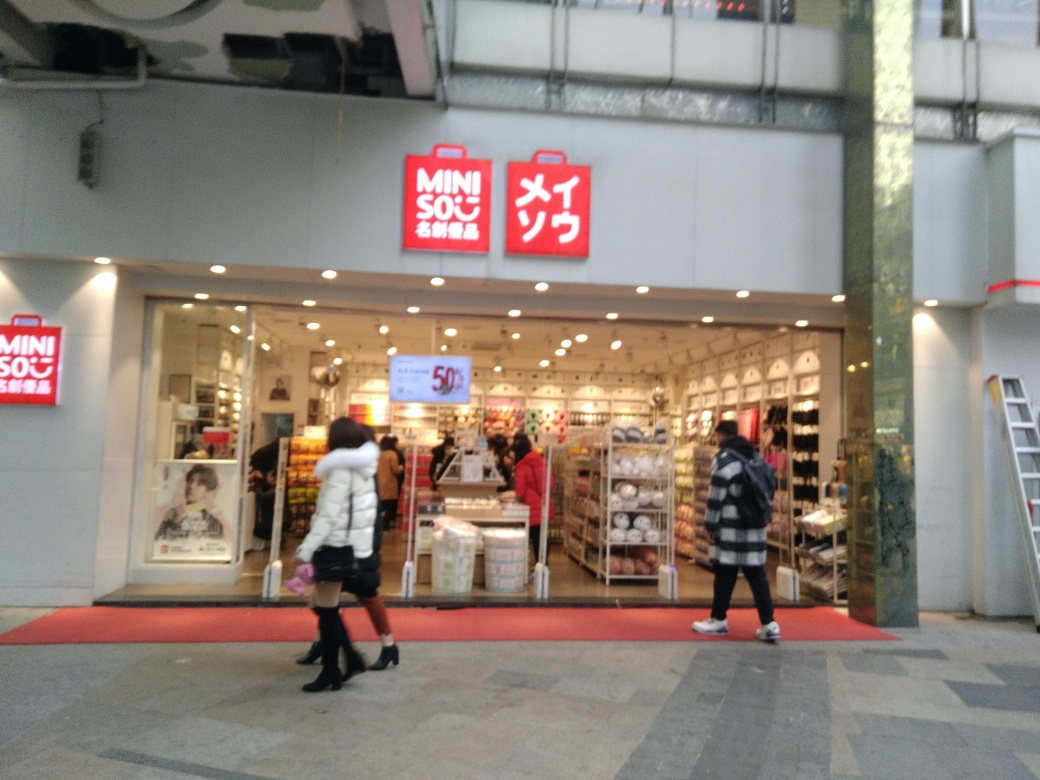How clear is the text on the storefront?
A. Clear and distinguishable
B. Partially obscured
C. Blurry and illegible The text on the storefront is predominantly clear and distinguishable. The red signage bearing the name of the store is in sharp contrast with the white background, making it highly readable even from a distance. Additionally, the smaller text underneath the main sign appears legible, though it is less prominent. Overall, visibility is quite high, making option A the most accurate choice. 